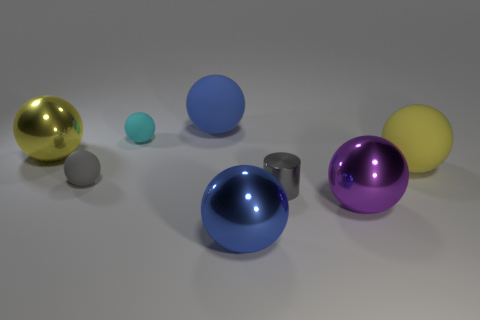How many blue spheres must be subtracted to get 1 blue spheres? 1 Subtract 2 balls. How many balls are left? 5 Subtract all purple balls. How many balls are left? 6 Subtract all shiny balls. How many balls are left? 4 Subtract all gray balls. Subtract all cyan cylinders. How many balls are left? 6 Add 1 large objects. How many objects exist? 9 Subtract all balls. How many objects are left? 1 Add 7 big yellow metallic spheres. How many big yellow metallic spheres are left? 8 Add 2 big rubber spheres. How many big rubber spheres exist? 4 Subtract 0 brown spheres. How many objects are left? 8 